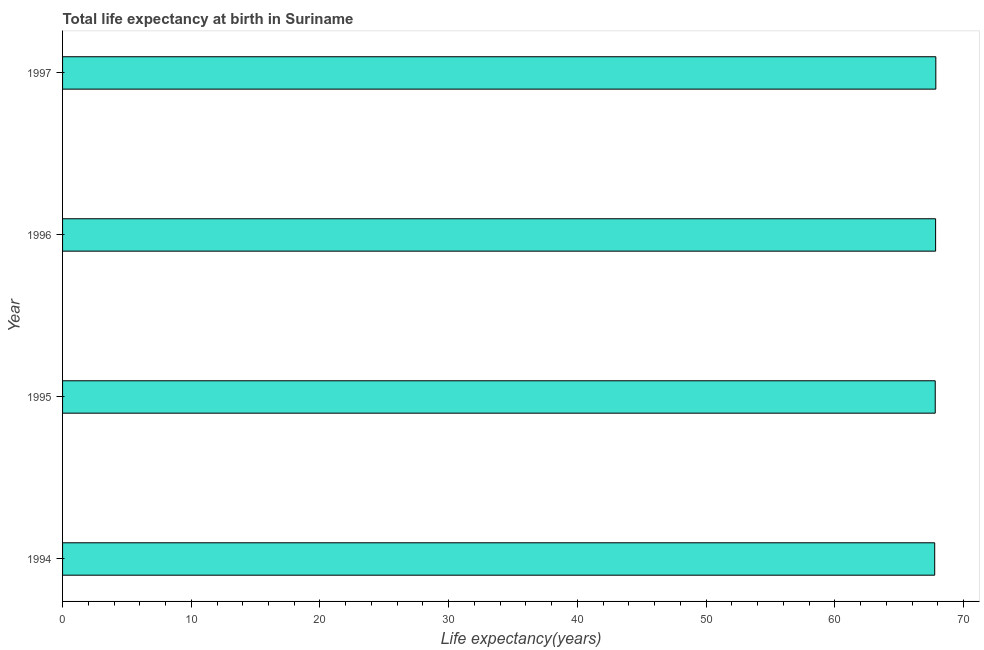Does the graph contain any zero values?
Give a very brief answer. No. What is the title of the graph?
Your response must be concise. Total life expectancy at birth in Suriname. What is the label or title of the X-axis?
Offer a terse response. Life expectancy(years). What is the label or title of the Y-axis?
Your answer should be very brief. Year. What is the life expectancy at birth in 1995?
Provide a succinct answer. 67.81. Across all years, what is the maximum life expectancy at birth?
Offer a very short reply. 67.85. Across all years, what is the minimum life expectancy at birth?
Offer a very short reply. 67.76. In which year was the life expectancy at birth minimum?
Make the answer very short. 1994. What is the sum of the life expectancy at birth?
Ensure brevity in your answer.  271.26. What is the difference between the life expectancy at birth in 1995 and 1997?
Make the answer very short. -0.05. What is the average life expectancy at birth per year?
Your answer should be compact. 67.81. What is the median life expectancy at birth?
Ensure brevity in your answer.  67.82. In how many years, is the life expectancy at birth greater than 34 years?
Offer a very short reply. 4. Do a majority of the years between 1995 and 1994 (inclusive) have life expectancy at birth greater than 8 years?
Offer a very short reply. No. What is the ratio of the life expectancy at birth in 1994 to that in 1995?
Offer a terse response. 1. Is the difference between the life expectancy at birth in 1994 and 1996 greater than the difference between any two years?
Your response must be concise. No. What is the difference between the highest and the second highest life expectancy at birth?
Offer a very short reply. 0.02. What is the difference between the highest and the lowest life expectancy at birth?
Offer a terse response. 0.09. In how many years, is the life expectancy at birth greater than the average life expectancy at birth taken over all years?
Your response must be concise. 2. Are all the bars in the graph horizontal?
Offer a very short reply. Yes. What is the Life expectancy(years) in 1994?
Offer a very short reply. 67.76. What is the Life expectancy(years) in 1995?
Offer a very short reply. 67.81. What is the Life expectancy(years) of 1996?
Keep it short and to the point. 67.83. What is the Life expectancy(years) in 1997?
Offer a very short reply. 67.85. What is the difference between the Life expectancy(years) in 1994 and 1995?
Keep it short and to the point. -0.04. What is the difference between the Life expectancy(years) in 1994 and 1996?
Keep it short and to the point. -0.07. What is the difference between the Life expectancy(years) in 1994 and 1997?
Give a very brief answer. -0.09. What is the difference between the Life expectancy(years) in 1995 and 1996?
Keep it short and to the point. -0.03. What is the difference between the Life expectancy(years) in 1995 and 1997?
Your answer should be compact. -0.05. What is the difference between the Life expectancy(years) in 1996 and 1997?
Ensure brevity in your answer.  -0.02. What is the ratio of the Life expectancy(years) in 1994 to that in 1995?
Keep it short and to the point. 1. What is the ratio of the Life expectancy(years) in 1994 to that in 1996?
Keep it short and to the point. 1. What is the ratio of the Life expectancy(years) in 1994 to that in 1997?
Offer a very short reply. 1. What is the ratio of the Life expectancy(years) in 1995 to that in 1996?
Offer a very short reply. 1. What is the ratio of the Life expectancy(years) in 1995 to that in 1997?
Offer a very short reply. 1. What is the ratio of the Life expectancy(years) in 1996 to that in 1997?
Offer a terse response. 1. 